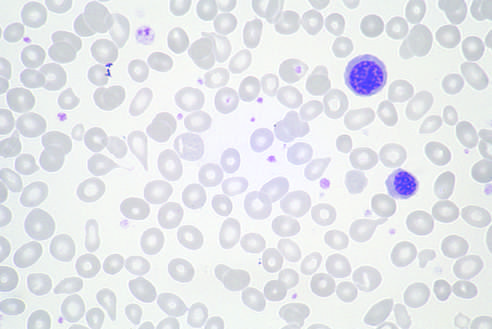re two nucleated erythroid precursors and several teardrop-shaped red cells evident?
Answer the question using a single word or phrase. Yes 